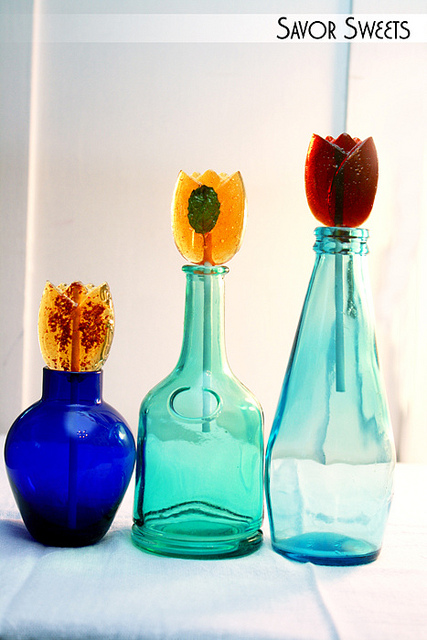Please identify all text content in this image. SAVOR SWEETS 